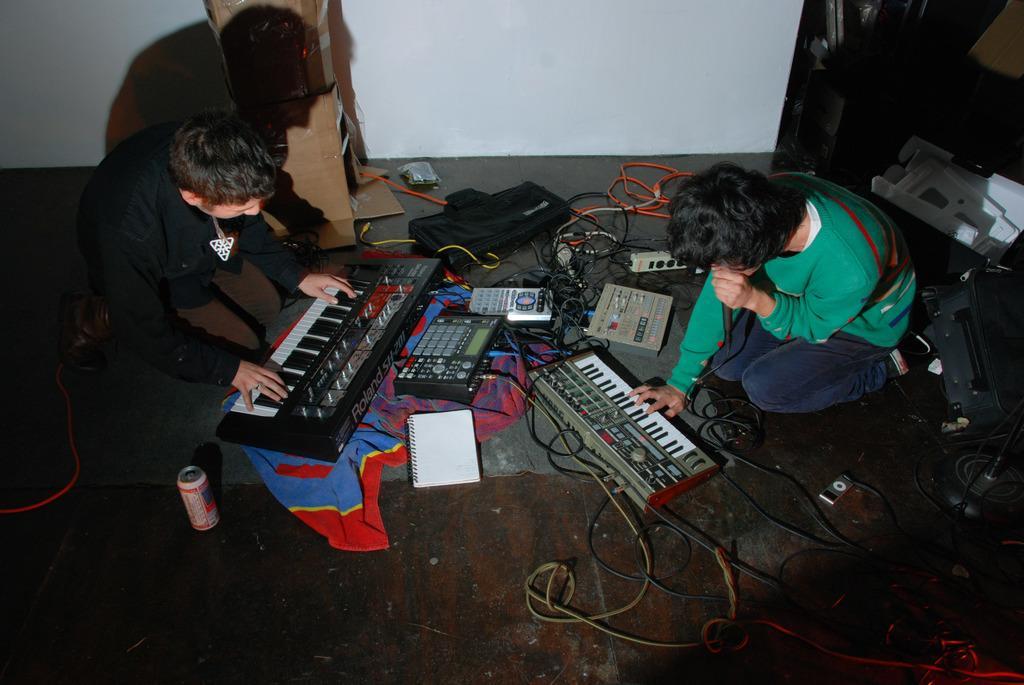How would you summarize this image in a sentence or two? Here we can see two persons are sitting on the floor. These are some musical instruments and there is a tin. On the background there is a wall and these are the cables. 